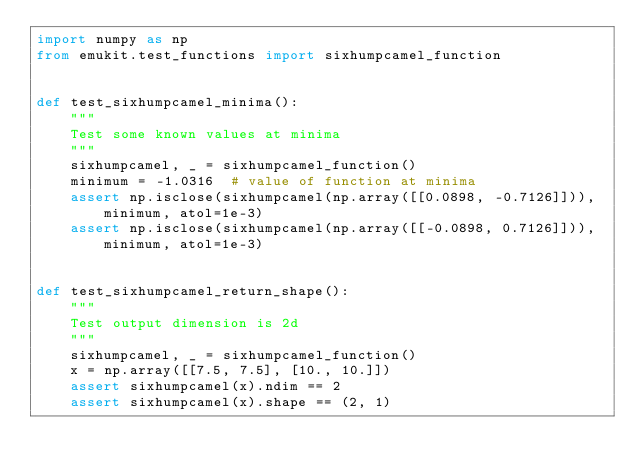<code> <loc_0><loc_0><loc_500><loc_500><_Python_>import numpy as np
from emukit.test_functions import sixhumpcamel_function


def test_sixhumpcamel_minima():
    """
    Test some known values at minima
    """
    sixhumpcamel, _ = sixhumpcamel_function()
    minimum = -1.0316  # value of function at minima
    assert np.isclose(sixhumpcamel(np.array([[0.0898, -0.7126]])), minimum, atol=1e-3)
    assert np.isclose(sixhumpcamel(np.array([[-0.0898, 0.7126]])), minimum, atol=1e-3)


def test_sixhumpcamel_return_shape():
    """
    Test output dimension is 2d
    """
    sixhumpcamel, _ = sixhumpcamel_function()
    x = np.array([[7.5, 7.5], [10., 10.]])
    assert sixhumpcamel(x).ndim == 2
    assert sixhumpcamel(x).shape == (2, 1)</code> 